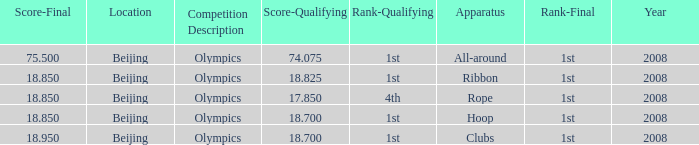On which apparatus did Kanayeva have a final score smaller than 75.5 and a qualifying score smaller than 18.7? Rope. 